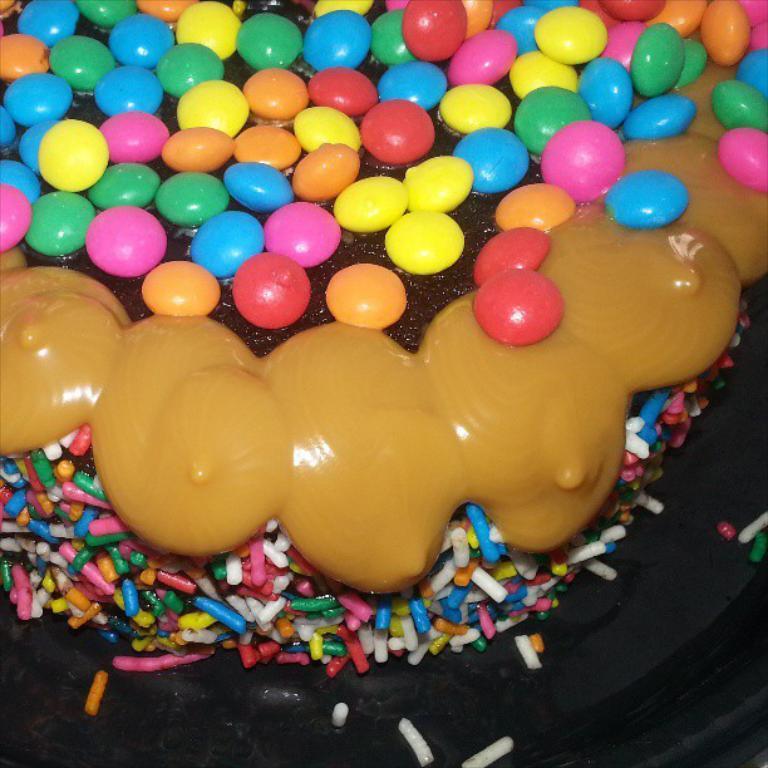Can you describe this image briefly? This looks like a cake. There are gems at the top. There is cream in the middle. 